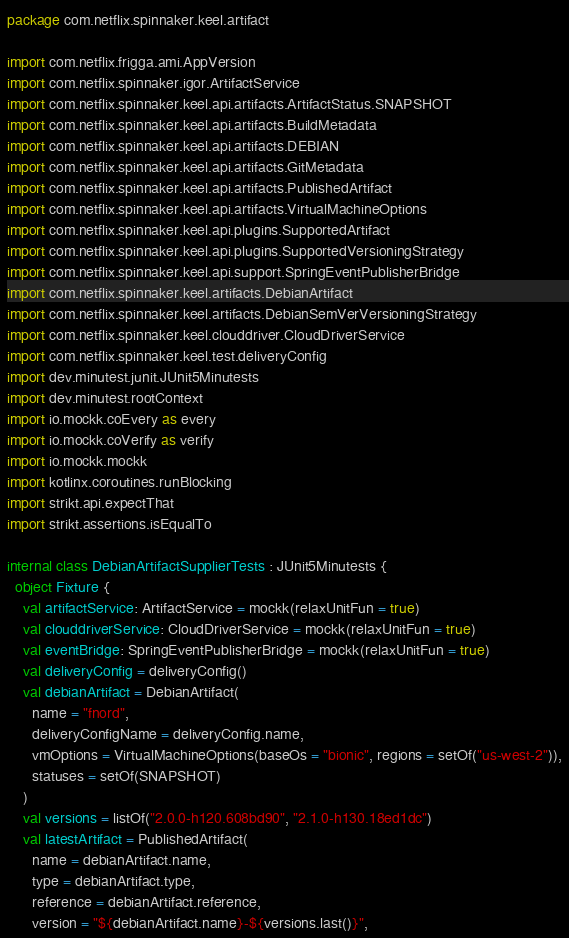<code> <loc_0><loc_0><loc_500><loc_500><_Kotlin_>package com.netflix.spinnaker.keel.artifact

import com.netflix.frigga.ami.AppVersion
import com.netflix.spinnaker.igor.ArtifactService
import com.netflix.spinnaker.keel.api.artifacts.ArtifactStatus.SNAPSHOT
import com.netflix.spinnaker.keel.api.artifacts.BuildMetadata
import com.netflix.spinnaker.keel.api.artifacts.DEBIAN
import com.netflix.spinnaker.keel.api.artifacts.GitMetadata
import com.netflix.spinnaker.keel.api.artifacts.PublishedArtifact
import com.netflix.spinnaker.keel.api.artifacts.VirtualMachineOptions
import com.netflix.spinnaker.keel.api.plugins.SupportedArtifact
import com.netflix.spinnaker.keel.api.plugins.SupportedVersioningStrategy
import com.netflix.spinnaker.keel.api.support.SpringEventPublisherBridge
import com.netflix.spinnaker.keel.artifacts.DebianArtifact
import com.netflix.spinnaker.keel.artifacts.DebianSemVerVersioningStrategy
import com.netflix.spinnaker.keel.clouddriver.CloudDriverService
import com.netflix.spinnaker.keel.test.deliveryConfig
import dev.minutest.junit.JUnit5Minutests
import dev.minutest.rootContext
import io.mockk.coEvery as every
import io.mockk.coVerify as verify
import io.mockk.mockk
import kotlinx.coroutines.runBlocking
import strikt.api.expectThat
import strikt.assertions.isEqualTo

internal class DebianArtifactSupplierTests : JUnit5Minutests {
  object Fixture {
    val artifactService: ArtifactService = mockk(relaxUnitFun = true)
    val clouddriverService: CloudDriverService = mockk(relaxUnitFun = true)
    val eventBridge: SpringEventPublisherBridge = mockk(relaxUnitFun = true)
    val deliveryConfig = deliveryConfig()
    val debianArtifact = DebianArtifact(
      name = "fnord",
      deliveryConfigName = deliveryConfig.name,
      vmOptions = VirtualMachineOptions(baseOs = "bionic", regions = setOf("us-west-2")),
      statuses = setOf(SNAPSHOT)
    )
    val versions = listOf("2.0.0-h120.608bd90", "2.1.0-h130.18ed1dc")
    val latestArtifact = PublishedArtifact(
      name = debianArtifact.name,
      type = debianArtifact.type,
      reference = debianArtifact.reference,
      version = "${debianArtifact.name}-${versions.last()}",</code> 